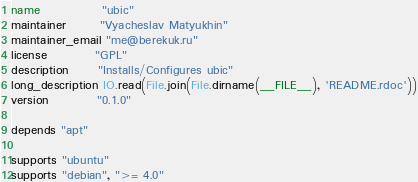<code> <loc_0><loc_0><loc_500><loc_500><_Ruby_>name             "ubic"
maintainer       "Vyacheslav Matyukhin"
maintainer_email "me@berekuk.ru"
license          "GPL"
description      "Installs/Configures ubic"
long_description IO.read(File.join(File.dirname(__FILE__), 'README.rdoc'))
version          "0.1.0"

depends "apt"

supports "ubuntu"
supports "debian", ">= 4.0"
</code> 